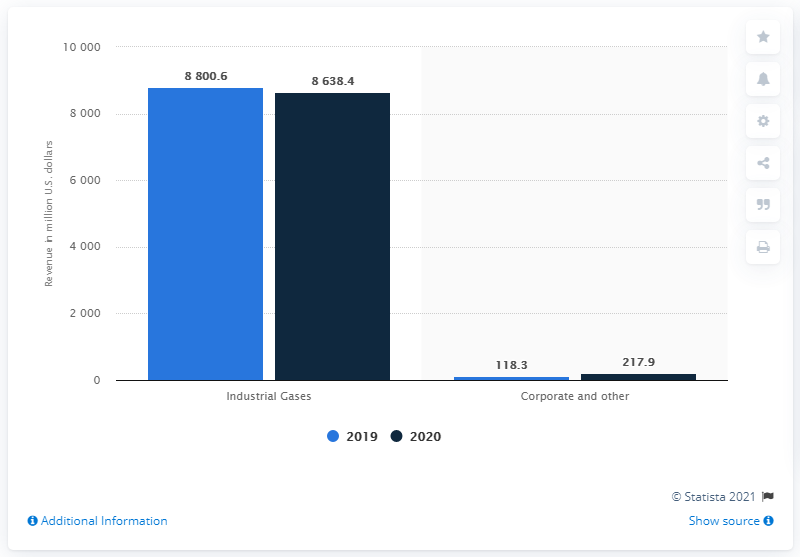Draw attention to some important aspects in this diagram. Air Products and Chemicals generated an estimated revenue of 86,384.4 in 2020. 